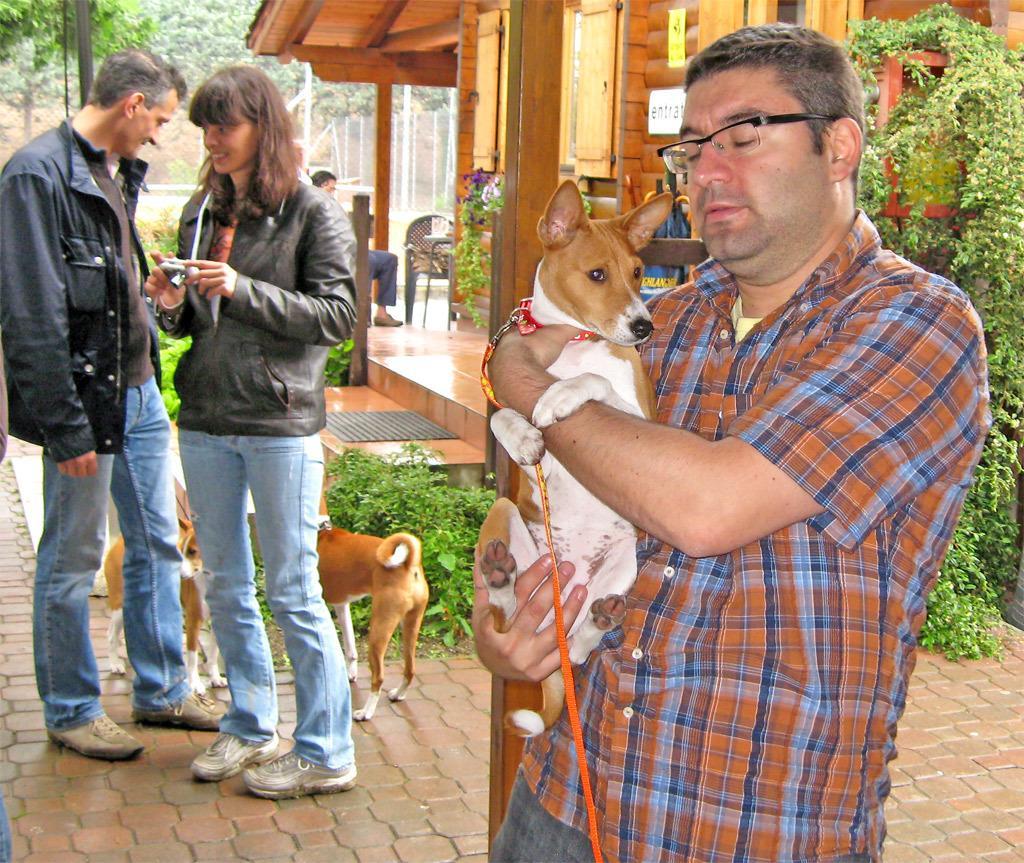Could you give a brief overview of what you see in this image? On the background we can see trees. This is a house. Near to the house we can see plants. Here we can see a woman holding a camera in her hands and smiling. Here we can see a man standing near to the women. These are dogs. Here we can see a man wearing spectacles and holding a dog with his hands. We can see chair near to the house and also person sitting on a chair. 